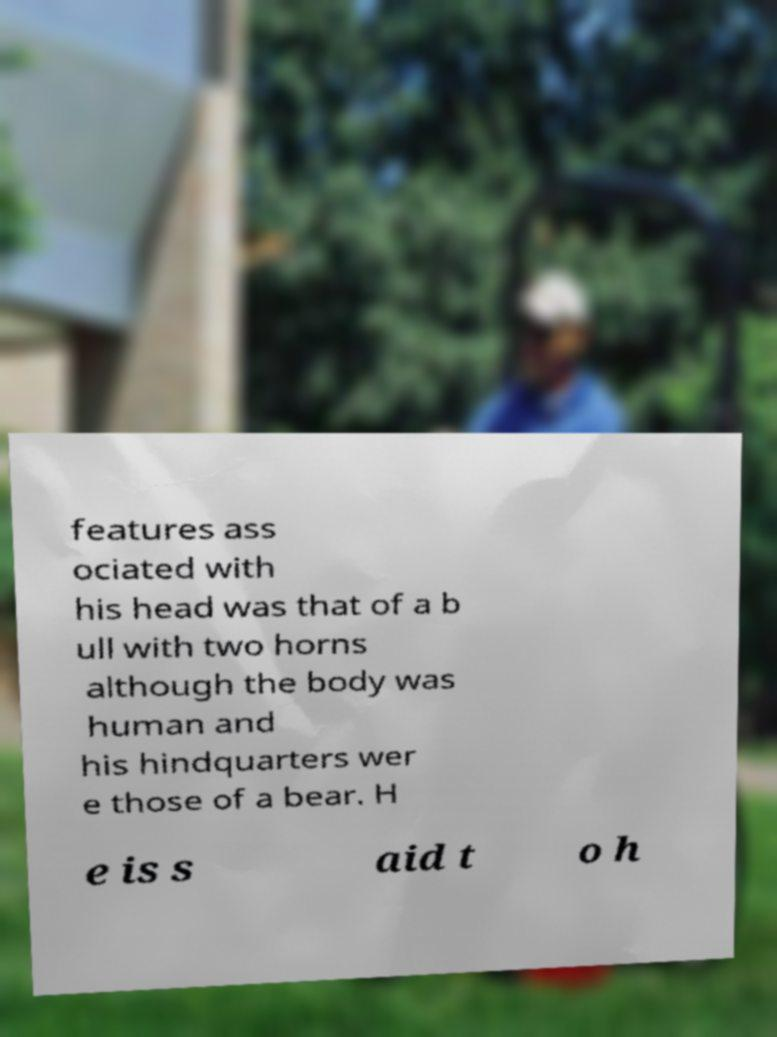Could you extract and type out the text from this image? features ass ociated with his head was that of a b ull with two horns although the body was human and his hindquarters wer e those of a bear. H e is s aid t o h 